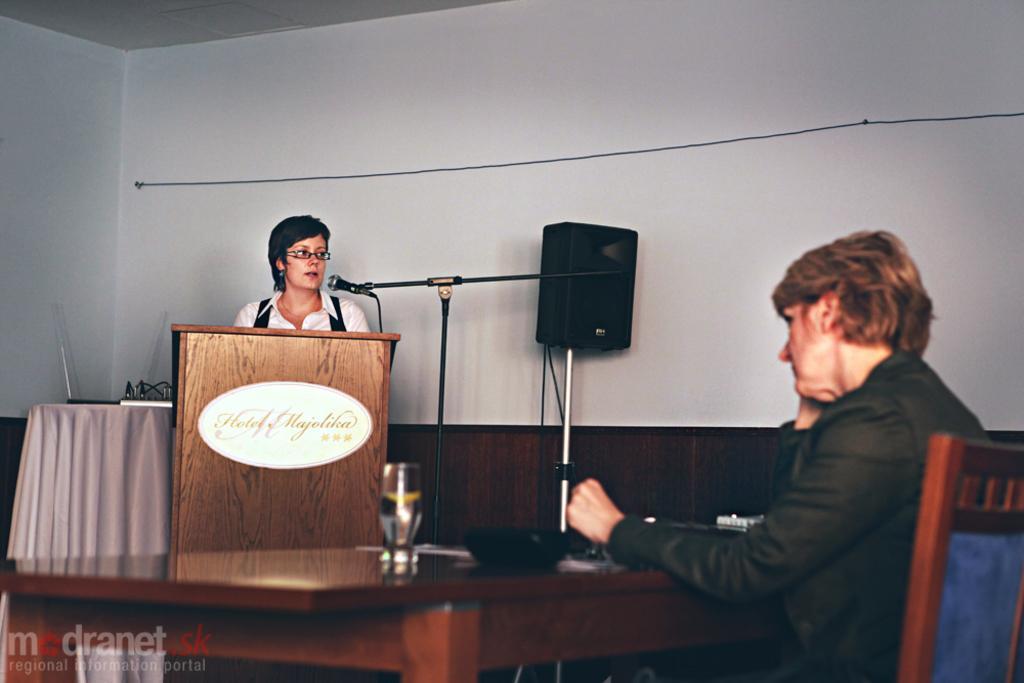How would you summarize this image in a sentence or two? In this picture we can see a woman sitting on a chair near the table & on the right side, we can see a woman standing in front of a mike. 